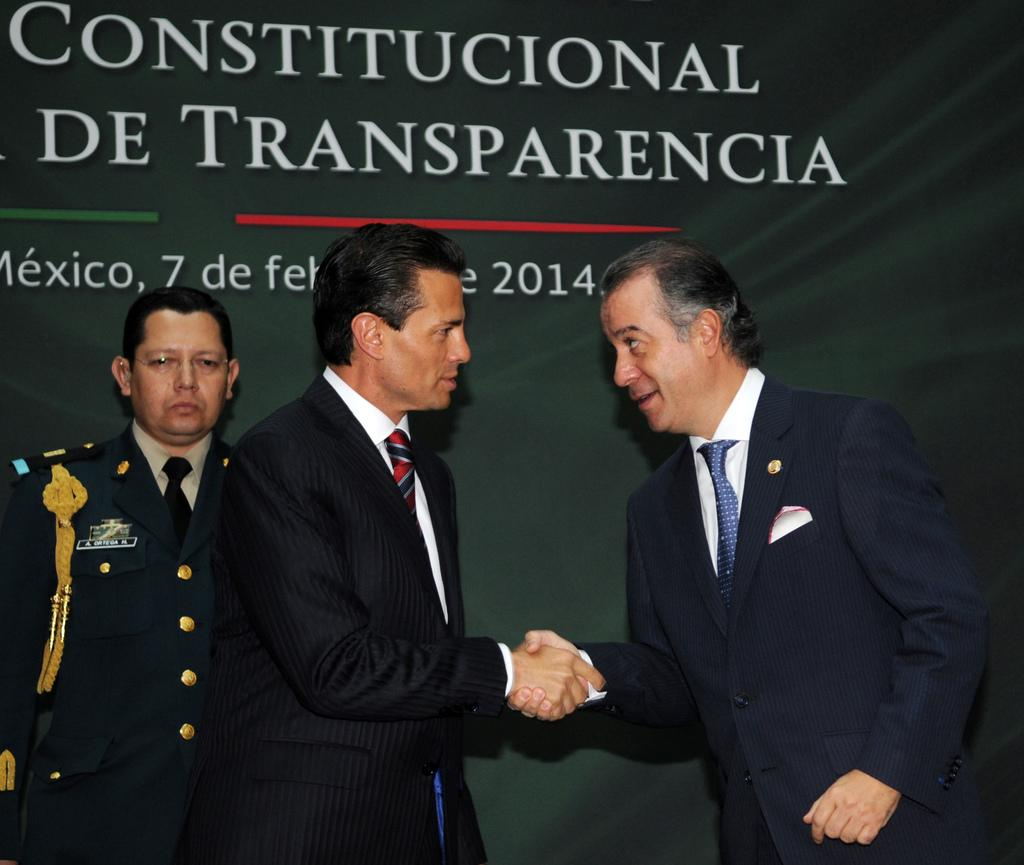How many people are in the image? There are two men in the image. What are the men doing in the image? The men are shaking hands. Can you describe the attire of one of the men? One man is wearing a shirt, blazer, tie, and trousers. Where is the man in the shirt, blazer, tie, and trousers standing in relation to the banner? The man in the shirt, blazer, tie, and trousers is standing near a banner. What type of rhythm can be heard in the background of the image? There is no audible rhythm present in the image, as it is a still photograph. 